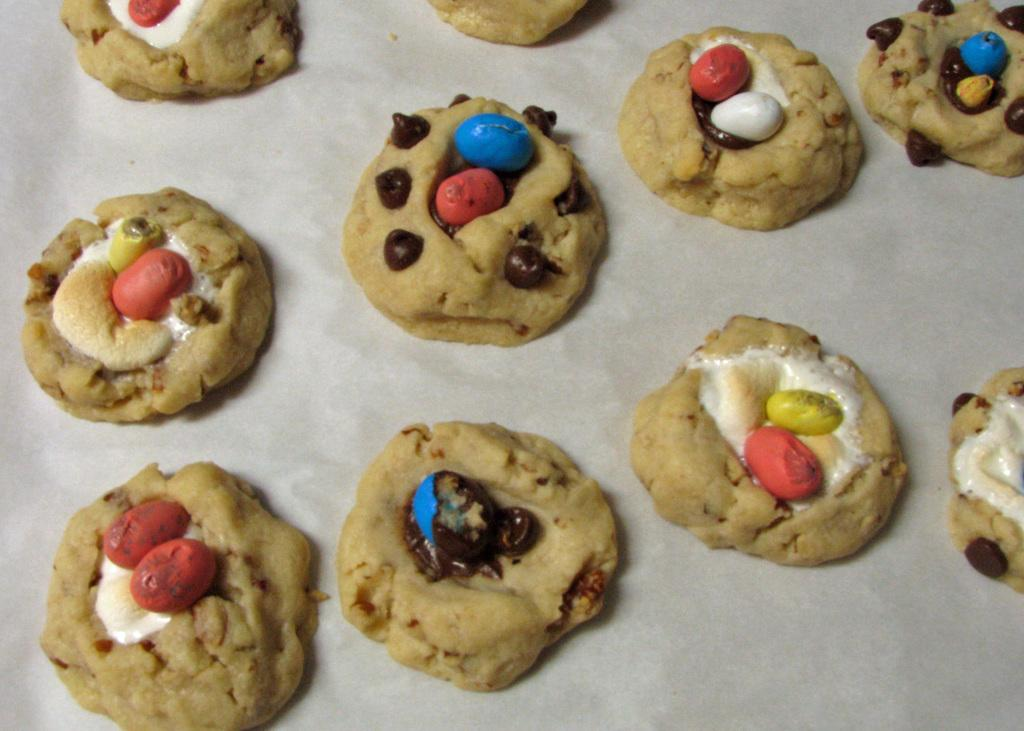What type of food can be seen in the image? There are cookies in the image. What color is the background at the bottom of the image? The bottom of the image has a white color background. What type of teeth can be seen in the image? There are no teeth present in the image, as it features cookies and a white background. 